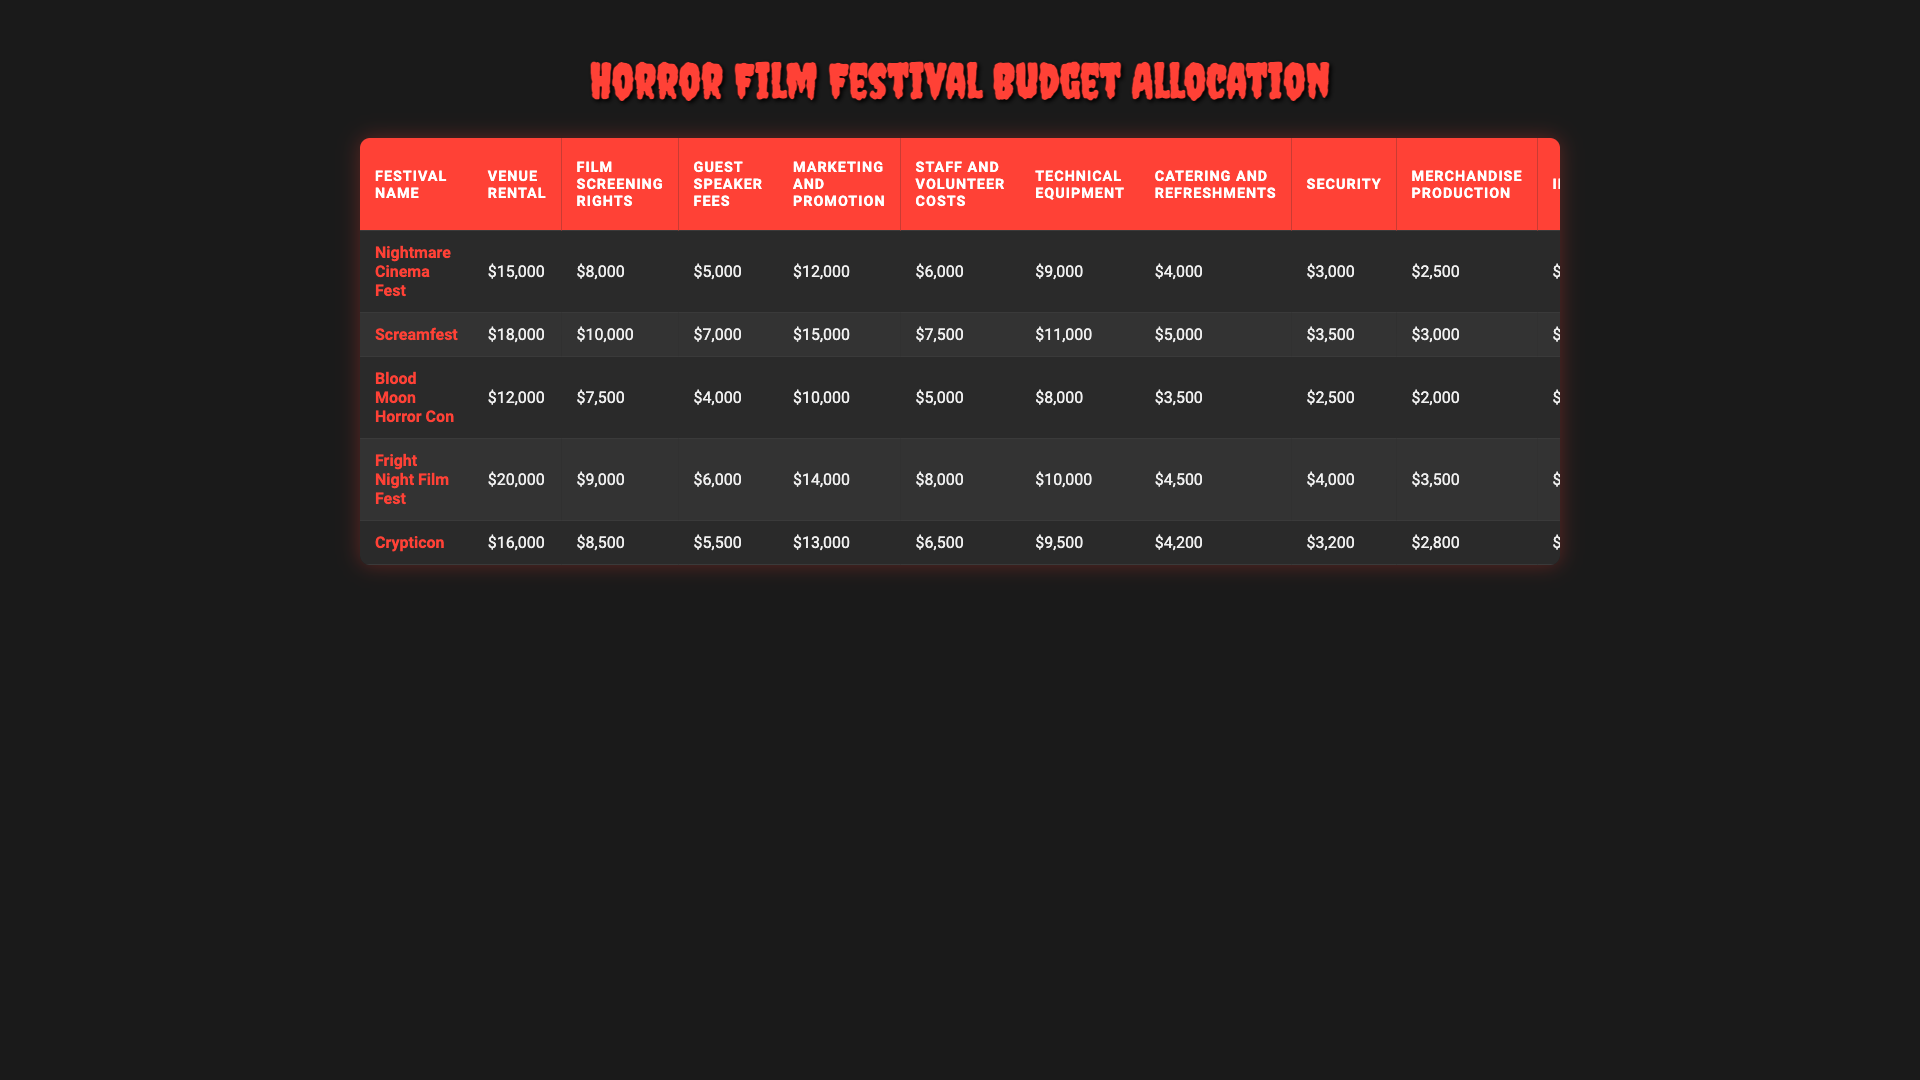What is the highest budget allocation for venue rental among the festivals? The festival with the highest venue rental cost can be found by comparing all the values in the "Venue Rental" column. Screamfest has the highest value at $18,000.
Answer: $18,000 Which festival allocated the least amount for guest speaker fees? By looking at the "Guest Speaker Fees" column, we can identify the lowest value. Blood Moon Horror Con has the lowest fee at $4,000.
Answer: $4,000 What is the total marketing and promotion budget for all festivals combined? To get the total marketing budget, sum all values in the "Marketing and Promotion" column: 12000 + 15000 + 10000 + 14000 + 13000 = 74000.
Answer: $74,000 Which festival has a higher total budget: Nightmare Cinema Fest or Crypticon? Calculate the total budget for each festival by summing all budget categories for each one. Nightmare Cinema Fest: $15,000 + $8,000 + $5,000 + $12,000 + $6,000 + $9,000 + $4,000 + $3,000 + $2,000 + $3,500 + $1,500 = $64,000. Crypticon: $16,000 + $8,500 + $5,500 + $13,000 + $6,500 + $9,500 + $4,200 + $3,200 + $2,800 + $2,100 + $3,800 + $1,600 = $70,200. Since Crypticon has a higher total, it is the answer.
Answer: Crypticon Is the budget for special effects and décor higher for Fright Night Film Fest than for Blood Moon Horror Con? To verify this, compare the values in the "Special Effects and Decor" column for both festivals. Fright Night Film Fest has $4,500, while Blood Moon Horror Con has $3,000. Since $4,500 is greater than $3,000, the statement is true.
Answer: Yes What is the average budget allocated for security across all festivals? The average budget can be calculated by summing all values in the "Security" column and dividing by the number of festivals (5). The total is 3000 + 3500 + 2500 + 4000 + 3200 = 16200. Thus, the average is 16200 / 5 = 3240.
Answer: $3,240 Which festival spent the most on technical equipment? Finding the maximum in the "Technical Equipment" column reveals that Screamfest spent the most at $11,000.
Answer: $11,000 What is the difference in budget for catering and refreshments between Fright Night Film Fest and Screamfest? To find the difference, subtract Screamfest's catering budget ($5,000) from Fright Night Film Fest's ($4,500). The difference is $4,500 - $5,000 = -$500. Therefore, Screamfest has $500 more for catering.
Answer: $500 How much more did Nightmare Cinema Fest spend on merchandise production compared to Blood Moon Horror Con? The figures in the "Merchandise Production" column show Nightmare Cinema Fest spent $2,500 and Blood Moon Horror Con spent $2,000. The difference is $2,500 - $2,000 = $500.
Answer: $500 Is it true that all festivals allocated more than $3,000 on awards and trophies? Checking the "Awards and Trophies" column, we find values of $1,500, $2,000, $1,200, $1,800, and $1,600 for each festival. Since $1,500 is less than $3,000, the statement is false.
Answer: No Which festival has the highest combined budget for marketing and technical equipment? Sum the values in the "Marketing and Promotion" and "Technical Equipment" columns for each festival. Screamfest has: $15,000 + $11,000 = $26,000, while Nightmare Cinema Fest has $12,000 + $9,000 = $21,000, and so on. The highest total is for Screamfest at $26,000.
Answer: Screamfest 